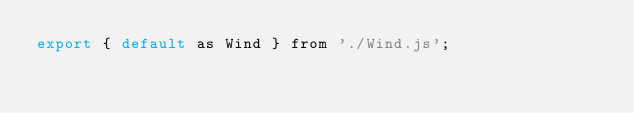<code> <loc_0><loc_0><loc_500><loc_500><_JavaScript_>export { default as Wind } from './Wind.js';
</code> 